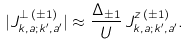Convert formula to latex. <formula><loc_0><loc_0><loc_500><loc_500>| J ^ { \perp \, ( \pm 1 ) } _ { k , a ; k ^ { \prime } , a ^ { \prime } } | \approx \frac { \Delta _ { \pm 1 } } { U } \, J ^ { z \, ( \pm 1 ) } _ { k , a ; k ^ { \prime } , a ^ { \prime } } .</formula> 